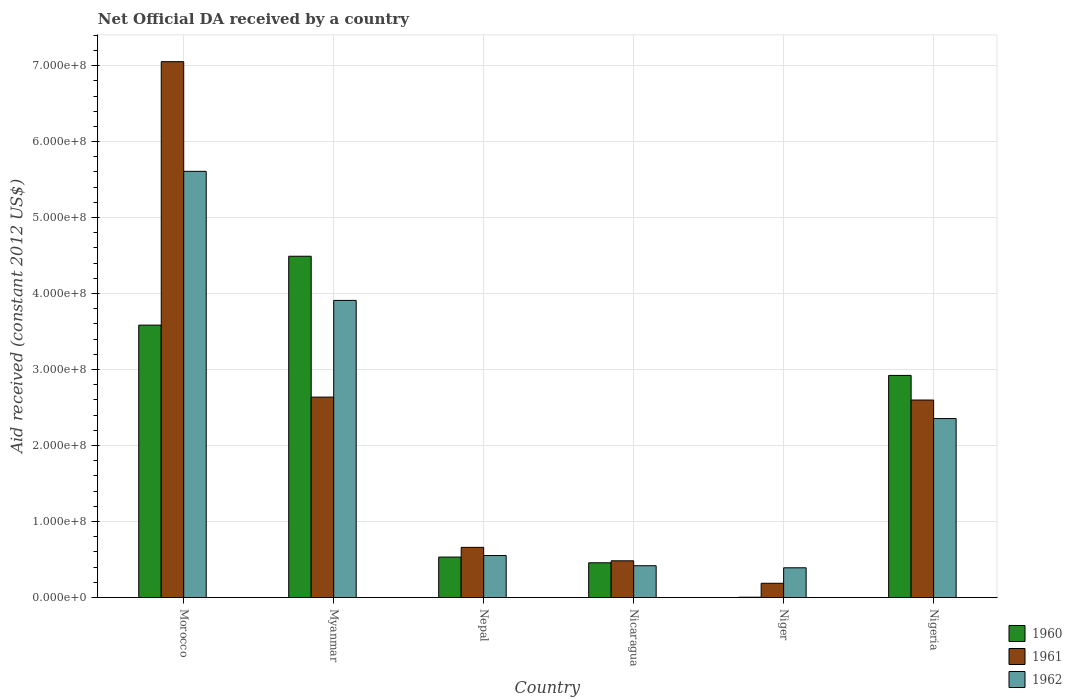How many groups of bars are there?
Offer a terse response. 6. Are the number of bars on each tick of the X-axis equal?
Make the answer very short. Yes. How many bars are there on the 2nd tick from the left?
Make the answer very short. 3. What is the label of the 2nd group of bars from the left?
Your answer should be very brief. Myanmar. What is the net official development assistance aid received in 1961 in Nigeria?
Your response must be concise. 2.60e+08. Across all countries, what is the maximum net official development assistance aid received in 1960?
Provide a short and direct response. 4.49e+08. Across all countries, what is the minimum net official development assistance aid received in 1961?
Your answer should be very brief. 1.88e+07. In which country was the net official development assistance aid received in 1960 maximum?
Your answer should be very brief. Myanmar. In which country was the net official development assistance aid received in 1962 minimum?
Your answer should be compact. Niger. What is the total net official development assistance aid received in 1961 in the graph?
Your answer should be very brief. 1.36e+09. What is the difference between the net official development assistance aid received in 1961 in Morocco and that in Myanmar?
Provide a short and direct response. 4.41e+08. What is the difference between the net official development assistance aid received in 1962 in Niger and the net official development assistance aid received in 1960 in Morocco?
Give a very brief answer. -3.19e+08. What is the average net official development assistance aid received in 1961 per country?
Provide a short and direct response. 2.27e+08. What is the difference between the net official development assistance aid received of/in 1961 and net official development assistance aid received of/in 1960 in Niger?
Provide a succinct answer. 1.84e+07. What is the ratio of the net official development assistance aid received in 1961 in Nicaragua to that in Niger?
Your response must be concise. 2.58. Is the net official development assistance aid received in 1961 in Morocco less than that in Nigeria?
Offer a very short reply. No. What is the difference between the highest and the second highest net official development assistance aid received in 1962?
Offer a terse response. 3.25e+08. What is the difference between the highest and the lowest net official development assistance aid received in 1960?
Offer a terse response. 4.49e+08. In how many countries, is the net official development assistance aid received in 1962 greater than the average net official development assistance aid received in 1962 taken over all countries?
Provide a succinct answer. 3. What does the 3rd bar from the left in Nicaragua represents?
Offer a terse response. 1962. What does the 2nd bar from the right in Nepal represents?
Offer a very short reply. 1961. Is it the case that in every country, the sum of the net official development assistance aid received in 1961 and net official development assistance aid received in 1962 is greater than the net official development assistance aid received in 1960?
Offer a very short reply. Yes. How many bars are there?
Provide a short and direct response. 18. How many countries are there in the graph?
Provide a short and direct response. 6. Does the graph contain grids?
Provide a succinct answer. Yes. Where does the legend appear in the graph?
Offer a terse response. Bottom right. What is the title of the graph?
Offer a terse response. Net Official DA received by a country. Does "1974" appear as one of the legend labels in the graph?
Your answer should be very brief. No. What is the label or title of the Y-axis?
Make the answer very short. Aid received (constant 2012 US$). What is the Aid received (constant 2012 US$) of 1960 in Morocco?
Give a very brief answer. 3.58e+08. What is the Aid received (constant 2012 US$) in 1961 in Morocco?
Your response must be concise. 7.05e+08. What is the Aid received (constant 2012 US$) in 1962 in Morocco?
Offer a terse response. 5.61e+08. What is the Aid received (constant 2012 US$) of 1960 in Myanmar?
Provide a short and direct response. 4.49e+08. What is the Aid received (constant 2012 US$) in 1961 in Myanmar?
Provide a succinct answer. 2.64e+08. What is the Aid received (constant 2012 US$) of 1962 in Myanmar?
Give a very brief answer. 3.91e+08. What is the Aid received (constant 2012 US$) in 1960 in Nepal?
Offer a terse response. 5.32e+07. What is the Aid received (constant 2012 US$) in 1961 in Nepal?
Give a very brief answer. 6.60e+07. What is the Aid received (constant 2012 US$) in 1962 in Nepal?
Provide a succinct answer. 5.53e+07. What is the Aid received (constant 2012 US$) of 1960 in Nicaragua?
Provide a short and direct response. 4.57e+07. What is the Aid received (constant 2012 US$) in 1961 in Nicaragua?
Provide a succinct answer. 4.83e+07. What is the Aid received (constant 2012 US$) of 1962 in Nicaragua?
Make the answer very short. 4.18e+07. What is the Aid received (constant 2012 US$) of 1961 in Niger?
Your answer should be compact. 1.88e+07. What is the Aid received (constant 2012 US$) of 1962 in Niger?
Your answer should be compact. 3.91e+07. What is the Aid received (constant 2012 US$) of 1960 in Nigeria?
Your response must be concise. 2.92e+08. What is the Aid received (constant 2012 US$) of 1961 in Nigeria?
Keep it short and to the point. 2.60e+08. What is the Aid received (constant 2012 US$) in 1962 in Nigeria?
Your answer should be compact. 2.36e+08. Across all countries, what is the maximum Aid received (constant 2012 US$) in 1960?
Provide a succinct answer. 4.49e+08. Across all countries, what is the maximum Aid received (constant 2012 US$) in 1961?
Offer a terse response. 7.05e+08. Across all countries, what is the maximum Aid received (constant 2012 US$) in 1962?
Make the answer very short. 5.61e+08. Across all countries, what is the minimum Aid received (constant 2012 US$) of 1960?
Offer a terse response. 4.10e+05. Across all countries, what is the minimum Aid received (constant 2012 US$) of 1961?
Make the answer very short. 1.88e+07. Across all countries, what is the minimum Aid received (constant 2012 US$) in 1962?
Provide a succinct answer. 3.91e+07. What is the total Aid received (constant 2012 US$) of 1960 in the graph?
Ensure brevity in your answer.  1.20e+09. What is the total Aid received (constant 2012 US$) of 1961 in the graph?
Offer a very short reply. 1.36e+09. What is the total Aid received (constant 2012 US$) of 1962 in the graph?
Offer a very short reply. 1.32e+09. What is the difference between the Aid received (constant 2012 US$) of 1960 in Morocco and that in Myanmar?
Your answer should be compact. -9.06e+07. What is the difference between the Aid received (constant 2012 US$) of 1961 in Morocco and that in Myanmar?
Ensure brevity in your answer.  4.41e+08. What is the difference between the Aid received (constant 2012 US$) of 1962 in Morocco and that in Myanmar?
Ensure brevity in your answer.  1.70e+08. What is the difference between the Aid received (constant 2012 US$) in 1960 in Morocco and that in Nepal?
Ensure brevity in your answer.  3.05e+08. What is the difference between the Aid received (constant 2012 US$) of 1961 in Morocco and that in Nepal?
Provide a short and direct response. 6.39e+08. What is the difference between the Aid received (constant 2012 US$) of 1962 in Morocco and that in Nepal?
Ensure brevity in your answer.  5.06e+08. What is the difference between the Aid received (constant 2012 US$) of 1960 in Morocco and that in Nicaragua?
Your answer should be compact. 3.13e+08. What is the difference between the Aid received (constant 2012 US$) in 1961 in Morocco and that in Nicaragua?
Your response must be concise. 6.57e+08. What is the difference between the Aid received (constant 2012 US$) of 1962 in Morocco and that in Nicaragua?
Provide a succinct answer. 5.19e+08. What is the difference between the Aid received (constant 2012 US$) of 1960 in Morocco and that in Niger?
Give a very brief answer. 3.58e+08. What is the difference between the Aid received (constant 2012 US$) in 1961 in Morocco and that in Niger?
Make the answer very short. 6.86e+08. What is the difference between the Aid received (constant 2012 US$) in 1962 in Morocco and that in Niger?
Ensure brevity in your answer.  5.22e+08. What is the difference between the Aid received (constant 2012 US$) of 1960 in Morocco and that in Nigeria?
Offer a very short reply. 6.62e+07. What is the difference between the Aid received (constant 2012 US$) of 1961 in Morocco and that in Nigeria?
Your answer should be very brief. 4.45e+08. What is the difference between the Aid received (constant 2012 US$) of 1962 in Morocco and that in Nigeria?
Ensure brevity in your answer.  3.25e+08. What is the difference between the Aid received (constant 2012 US$) of 1960 in Myanmar and that in Nepal?
Provide a short and direct response. 3.96e+08. What is the difference between the Aid received (constant 2012 US$) of 1961 in Myanmar and that in Nepal?
Make the answer very short. 1.98e+08. What is the difference between the Aid received (constant 2012 US$) in 1962 in Myanmar and that in Nepal?
Your answer should be very brief. 3.36e+08. What is the difference between the Aid received (constant 2012 US$) in 1960 in Myanmar and that in Nicaragua?
Offer a terse response. 4.03e+08. What is the difference between the Aid received (constant 2012 US$) of 1961 in Myanmar and that in Nicaragua?
Give a very brief answer. 2.15e+08. What is the difference between the Aid received (constant 2012 US$) of 1962 in Myanmar and that in Nicaragua?
Give a very brief answer. 3.49e+08. What is the difference between the Aid received (constant 2012 US$) of 1960 in Myanmar and that in Niger?
Your answer should be very brief. 4.49e+08. What is the difference between the Aid received (constant 2012 US$) in 1961 in Myanmar and that in Niger?
Provide a succinct answer. 2.45e+08. What is the difference between the Aid received (constant 2012 US$) in 1962 in Myanmar and that in Niger?
Ensure brevity in your answer.  3.52e+08. What is the difference between the Aid received (constant 2012 US$) of 1960 in Myanmar and that in Nigeria?
Your answer should be compact. 1.57e+08. What is the difference between the Aid received (constant 2012 US$) in 1961 in Myanmar and that in Nigeria?
Make the answer very short. 3.86e+06. What is the difference between the Aid received (constant 2012 US$) of 1962 in Myanmar and that in Nigeria?
Offer a terse response. 1.56e+08. What is the difference between the Aid received (constant 2012 US$) in 1960 in Nepal and that in Nicaragua?
Offer a very short reply. 7.52e+06. What is the difference between the Aid received (constant 2012 US$) in 1961 in Nepal and that in Nicaragua?
Offer a very short reply. 1.77e+07. What is the difference between the Aid received (constant 2012 US$) in 1962 in Nepal and that in Nicaragua?
Provide a succinct answer. 1.34e+07. What is the difference between the Aid received (constant 2012 US$) of 1960 in Nepal and that in Niger?
Give a very brief answer. 5.28e+07. What is the difference between the Aid received (constant 2012 US$) in 1961 in Nepal and that in Niger?
Ensure brevity in your answer.  4.72e+07. What is the difference between the Aid received (constant 2012 US$) in 1962 in Nepal and that in Niger?
Keep it short and to the point. 1.62e+07. What is the difference between the Aid received (constant 2012 US$) of 1960 in Nepal and that in Nigeria?
Your response must be concise. -2.39e+08. What is the difference between the Aid received (constant 2012 US$) in 1961 in Nepal and that in Nigeria?
Keep it short and to the point. -1.94e+08. What is the difference between the Aid received (constant 2012 US$) of 1962 in Nepal and that in Nigeria?
Offer a terse response. -1.80e+08. What is the difference between the Aid received (constant 2012 US$) in 1960 in Nicaragua and that in Niger?
Give a very brief answer. 4.53e+07. What is the difference between the Aid received (constant 2012 US$) of 1961 in Nicaragua and that in Niger?
Your answer should be compact. 2.96e+07. What is the difference between the Aid received (constant 2012 US$) in 1962 in Nicaragua and that in Niger?
Your answer should be compact. 2.72e+06. What is the difference between the Aid received (constant 2012 US$) in 1960 in Nicaragua and that in Nigeria?
Give a very brief answer. -2.47e+08. What is the difference between the Aid received (constant 2012 US$) of 1961 in Nicaragua and that in Nigeria?
Make the answer very short. -2.12e+08. What is the difference between the Aid received (constant 2012 US$) of 1962 in Nicaragua and that in Nigeria?
Offer a terse response. -1.94e+08. What is the difference between the Aid received (constant 2012 US$) in 1960 in Niger and that in Nigeria?
Make the answer very short. -2.92e+08. What is the difference between the Aid received (constant 2012 US$) in 1961 in Niger and that in Nigeria?
Provide a short and direct response. -2.41e+08. What is the difference between the Aid received (constant 2012 US$) in 1962 in Niger and that in Nigeria?
Keep it short and to the point. -1.96e+08. What is the difference between the Aid received (constant 2012 US$) in 1960 in Morocco and the Aid received (constant 2012 US$) in 1961 in Myanmar?
Your answer should be very brief. 9.47e+07. What is the difference between the Aid received (constant 2012 US$) of 1960 in Morocco and the Aid received (constant 2012 US$) of 1962 in Myanmar?
Offer a terse response. -3.25e+07. What is the difference between the Aid received (constant 2012 US$) of 1961 in Morocco and the Aid received (constant 2012 US$) of 1962 in Myanmar?
Offer a very short reply. 3.14e+08. What is the difference between the Aid received (constant 2012 US$) of 1960 in Morocco and the Aid received (constant 2012 US$) of 1961 in Nepal?
Make the answer very short. 2.92e+08. What is the difference between the Aid received (constant 2012 US$) in 1960 in Morocco and the Aid received (constant 2012 US$) in 1962 in Nepal?
Your response must be concise. 3.03e+08. What is the difference between the Aid received (constant 2012 US$) of 1961 in Morocco and the Aid received (constant 2012 US$) of 1962 in Nepal?
Give a very brief answer. 6.50e+08. What is the difference between the Aid received (constant 2012 US$) of 1960 in Morocco and the Aid received (constant 2012 US$) of 1961 in Nicaragua?
Provide a succinct answer. 3.10e+08. What is the difference between the Aid received (constant 2012 US$) in 1960 in Morocco and the Aid received (constant 2012 US$) in 1962 in Nicaragua?
Make the answer very short. 3.17e+08. What is the difference between the Aid received (constant 2012 US$) of 1961 in Morocco and the Aid received (constant 2012 US$) of 1962 in Nicaragua?
Give a very brief answer. 6.63e+08. What is the difference between the Aid received (constant 2012 US$) of 1960 in Morocco and the Aid received (constant 2012 US$) of 1961 in Niger?
Offer a very short reply. 3.40e+08. What is the difference between the Aid received (constant 2012 US$) of 1960 in Morocco and the Aid received (constant 2012 US$) of 1962 in Niger?
Provide a short and direct response. 3.19e+08. What is the difference between the Aid received (constant 2012 US$) of 1961 in Morocco and the Aid received (constant 2012 US$) of 1962 in Niger?
Your answer should be compact. 6.66e+08. What is the difference between the Aid received (constant 2012 US$) in 1960 in Morocco and the Aid received (constant 2012 US$) in 1961 in Nigeria?
Offer a terse response. 9.86e+07. What is the difference between the Aid received (constant 2012 US$) of 1960 in Morocco and the Aid received (constant 2012 US$) of 1962 in Nigeria?
Your response must be concise. 1.23e+08. What is the difference between the Aid received (constant 2012 US$) of 1961 in Morocco and the Aid received (constant 2012 US$) of 1962 in Nigeria?
Keep it short and to the point. 4.70e+08. What is the difference between the Aid received (constant 2012 US$) in 1960 in Myanmar and the Aid received (constant 2012 US$) in 1961 in Nepal?
Your answer should be compact. 3.83e+08. What is the difference between the Aid received (constant 2012 US$) of 1960 in Myanmar and the Aid received (constant 2012 US$) of 1962 in Nepal?
Provide a short and direct response. 3.94e+08. What is the difference between the Aid received (constant 2012 US$) of 1961 in Myanmar and the Aid received (constant 2012 US$) of 1962 in Nepal?
Provide a succinct answer. 2.08e+08. What is the difference between the Aid received (constant 2012 US$) in 1960 in Myanmar and the Aid received (constant 2012 US$) in 1961 in Nicaragua?
Provide a short and direct response. 4.01e+08. What is the difference between the Aid received (constant 2012 US$) of 1960 in Myanmar and the Aid received (constant 2012 US$) of 1962 in Nicaragua?
Your answer should be compact. 4.07e+08. What is the difference between the Aid received (constant 2012 US$) in 1961 in Myanmar and the Aid received (constant 2012 US$) in 1962 in Nicaragua?
Ensure brevity in your answer.  2.22e+08. What is the difference between the Aid received (constant 2012 US$) of 1960 in Myanmar and the Aid received (constant 2012 US$) of 1961 in Niger?
Provide a short and direct response. 4.30e+08. What is the difference between the Aid received (constant 2012 US$) of 1960 in Myanmar and the Aid received (constant 2012 US$) of 1962 in Niger?
Your response must be concise. 4.10e+08. What is the difference between the Aid received (constant 2012 US$) in 1961 in Myanmar and the Aid received (constant 2012 US$) in 1962 in Niger?
Make the answer very short. 2.25e+08. What is the difference between the Aid received (constant 2012 US$) of 1960 in Myanmar and the Aid received (constant 2012 US$) of 1961 in Nigeria?
Your answer should be very brief. 1.89e+08. What is the difference between the Aid received (constant 2012 US$) of 1960 in Myanmar and the Aid received (constant 2012 US$) of 1962 in Nigeria?
Your answer should be compact. 2.14e+08. What is the difference between the Aid received (constant 2012 US$) of 1961 in Myanmar and the Aid received (constant 2012 US$) of 1962 in Nigeria?
Ensure brevity in your answer.  2.82e+07. What is the difference between the Aid received (constant 2012 US$) in 1960 in Nepal and the Aid received (constant 2012 US$) in 1961 in Nicaragua?
Provide a succinct answer. 4.90e+06. What is the difference between the Aid received (constant 2012 US$) of 1960 in Nepal and the Aid received (constant 2012 US$) of 1962 in Nicaragua?
Your answer should be very brief. 1.14e+07. What is the difference between the Aid received (constant 2012 US$) in 1961 in Nepal and the Aid received (constant 2012 US$) in 1962 in Nicaragua?
Offer a very short reply. 2.42e+07. What is the difference between the Aid received (constant 2012 US$) of 1960 in Nepal and the Aid received (constant 2012 US$) of 1961 in Niger?
Provide a succinct answer. 3.45e+07. What is the difference between the Aid received (constant 2012 US$) in 1960 in Nepal and the Aid received (constant 2012 US$) in 1962 in Niger?
Make the answer very short. 1.41e+07. What is the difference between the Aid received (constant 2012 US$) in 1961 in Nepal and the Aid received (constant 2012 US$) in 1962 in Niger?
Offer a terse response. 2.69e+07. What is the difference between the Aid received (constant 2012 US$) of 1960 in Nepal and the Aid received (constant 2012 US$) of 1961 in Nigeria?
Provide a short and direct response. -2.07e+08. What is the difference between the Aid received (constant 2012 US$) of 1960 in Nepal and the Aid received (constant 2012 US$) of 1962 in Nigeria?
Offer a terse response. -1.82e+08. What is the difference between the Aid received (constant 2012 US$) of 1961 in Nepal and the Aid received (constant 2012 US$) of 1962 in Nigeria?
Your answer should be compact. -1.70e+08. What is the difference between the Aid received (constant 2012 US$) of 1960 in Nicaragua and the Aid received (constant 2012 US$) of 1961 in Niger?
Keep it short and to the point. 2.70e+07. What is the difference between the Aid received (constant 2012 US$) of 1960 in Nicaragua and the Aid received (constant 2012 US$) of 1962 in Niger?
Provide a short and direct response. 6.58e+06. What is the difference between the Aid received (constant 2012 US$) of 1961 in Nicaragua and the Aid received (constant 2012 US$) of 1962 in Niger?
Make the answer very short. 9.20e+06. What is the difference between the Aid received (constant 2012 US$) in 1960 in Nicaragua and the Aid received (constant 2012 US$) in 1961 in Nigeria?
Your answer should be compact. -2.14e+08. What is the difference between the Aid received (constant 2012 US$) of 1960 in Nicaragua and the Aid received (constant 2012 US$) of 1962 in Nigeria?
Offer a very short reply. -1.90e+08. What is the difference between the Aid received (constant 2012 US$) in 1961 in Nicaragua and the Aid received (constant 2012 US$) in 1962 in Nigeria?
Give a very brief answer. -1.87e+08. What is the difference between the Aid received (constant 2012 US$) of 1960 in Niger and the Aid received (constant 2012 US$) of 1961 in Nigeria?
Offer a terse response. -2.59e+08. What is the difference between the Aid received (constant 2012 US$) in 1960 in Niger and the Aid received (constant 2012 US$) in 1962 in Nigeria?
Provide a succinct answer. -2.35e+08. What is the difference between the Aid received (constant 2012 US$) of 1961 in Niger and the Aid received (constant 2012 US$) of 1962 in Nigeria?
Offer a terse response. -2.17e+08. What is the average Aid received (constant 2012 US$) of 1960 per country?
Provide a succinct answer. 2.00e+08. What is the average Aid received (constant 2012 US$) in 1961 per country?
Keep it short and to the point. 2.27e+08. What is the average Aid received (constant 2012 US$) of 1962 per country?
Provide a succinct answer. 2.21e+08. What is the difference between the Aid received (constant 2012 US$) of 1960 and Aid received (constant 2012 US$) of 1961 in Morocco?
Make the answer very short. -3.47e+08. What is the difference between the Aid received (constant 2012 US$) of 1960 and Aid received (constant 2012 US$) of 1962 in Morocco?
Provide a succinct answer. -2.02e+08. What is the difference between the Aid received (constant 2012 US$) in 1961 and Aid received (constant 2012 US$) in 1962 in Morocco?
Ensure brevity in your answer.  1.44e+08. What is the difference between the Aid received (constant 2012 US$) of 1960 and Aid received (constant 2012 US$) of 1961 in Myanmar?
Give a very brief answer. 1.85e+08. What is the difference between the Aid received (constant 2012 US$) of 1960 and Aid received (constant 2012 US$) of 1962 in Myanmar?
Your response must be concise. 5.81e+07. What is the difference between the Aid received (constant 2012 US$) in 1961 and Aid received (constant 2012 US$) in 1962 in Myanmar?
Offer a very short reply. -1.27e+08. What is the difference between the Aid received (constant 2012 US$) of 1960 and Aid received (constant 2012 US$) of 1961 in Nepal?
Offer a terse response. -1.28e+07. What is the difference between the Aid received (constant 2012 US$) in 1960 and Aid received (constant 2012 US$) in 1962 in Nepal?
Your answer should be very brief. -2.05e+06. What is the difference between the Aid received (constant 2012 US$) in 1961 and Aid received (constant 2012 US$) in 1962 in Nepal?
Your response must be concise. 1.07e+07. What is the difference between the Aid received (constant 2012 US$) of 1960 and Aid received (constant 2012 US$) of 1961 in Nicaragua?
Your response must be concise. -2.62e+06. What is the difference between the Aid received (constant 2012 US$) of 1960 and Aid received (constant 2012 US$) of 1962 in Nicaragua?
Your answer should be compact. 3.86e+06. What is the difference between the Aid received (constant 2012 US$) of 1961 and Aid received (constant 2012 US$) of 1962 in Nicaragua?
Provide a succinct answer. 6.48e+06. What is the difference between the Aid received (constant 2012 US$) in 1960 and Aid received (constant 2012 US$) in 1961 in Niger?
Ensure brevity in your answer.  -1.84e+07. What is the difference between the Aid received (constant 2012 US$) in 1960 and Aid received (constant 2012 US$) in 1962 in Niger?
Provide a short and direct response. -3.87e+07. What is the difference between the Aid received (constant 2012 US$) in 1961 and Aid received (constant 2012 US$) in 1962 in Niger?
Make the answer very short. -2.04e+07. What is the difference between the Aid received (constant 2012 US$) in 1960 and Aid received (constant 2012 US$) in 1961 in Nigeria?
Provide a succinct answer. 3.24e+07. What is the difference between the Aid received (constant 2012 US$) in 1960 and Aid received (constant 2012 US$) in 1962 in Nigeria?
Your answer should be compact. 5.68e+07. What is the difference between the Aid received (constant 2012 US$) of 1961 and Aid received (constant 2012 US$) of 1962 in Nigeria?
Ensure brevity in your answer.  2.44e+07. What is the ratio of the Aid received (constant 2012 US$) in 1960 in Morocco to that in Myanmar?
Your response must be concise. 0.8. What is the ratio of the Aid received (constant 2012 US$) of 1961 in Morocco to that in Myanmar?
Offer a very short reply. 2.67. What is the ratio of the Aid received (constant 2012 US$) of 1962 in Morocco to that in Myanmar?
Provide a succinct answer. 1.43. What is the ratio of the Aid received (constant 2012 US$) in 1960 in Morocco to that in Nepal?
Keep it short and to the point. 6.73. What is the ratio of the Aid received (constant 2012 US$) of 1961 in Morocco to that in Nepal?
Make the answer very short. 10.68. What is the ratio of the Aid received (constant 2012 US$) of 1962 in Morocco to that in Nepal?
Offer a terse response. 10.15. What is the ratio of the Aid received (constant 2012 US$) of 1960 in Morocco to that in Nicaragua?
Your answer should be compact. 7.84. What is the ratio of the Aid received (constant 2012 US$) of 1961 in Morocco to that in Nicaragua?
Give a very brief answer. 14.59. What is the ratio of the Aid received (constant 2012 US$) in 1962 in Morocco to that in Nicaragua?
Offer a very short reply. 13.4. What is the ratio of the Aid received (constant 2012 US$) of 1960 in Morocco to that in Niger?
Make the answer very short. 874.39. What is the ratio of the Aid received (constant 2012 US$) in 1961 in Morocco to that in Niger?
Your response must be concise. 37.59. What is the ratio of the Aid received (constant 2012 US$) in 1962 in Morocco to that in Niger?
Make the answer very short. 14.33. What is the ratio of the Aid received (constant 2012 US$) of 1960 in Morocco to that in Nigeria?
Keep it short and to the point. 1.23. What is the ratio of the Aid received (constant 2012 US$) in 1961 in Morocco to that in Nigeria?
Your answer should be very brief. 2.71. What is the ratio of the Aid received (constant 2012 US$) in 1962 in Morocco to that in Nigeria?
Give a very brief answer. 2.38. What is the ratio of the Aid received (constant 2012 US$) in 1960 in Myanmar to that in Nepal?
Your answer should be very brief. 8.44. What is the ratio of the Aid received (constant 2012 US$) in 1961 in Myanmar to that in Nepal?
Provide a succinct answer. 4. What is the ratio of the Aid received (constant 2012 US$) in 1962 in Myanmar to that in Nepal?
Offer a very short reply. 7.07. What is the ratio of the Aid received (constant 2012 US$) of 1960 in Myanmar to that in Nicaragua?
Ensure brevity in your answer.  9.83. What is the ratio of the Aid received (constant 2012 US$) of 1961 in Myanmar to that in Nicaragua?
Provide a succinct answer. 5.46. What is the ratio of the Aid received (constant 2012 US$) of 1962 in Myanmar to that in Nicaragua?
Ensure brevity in your answer.  9.34. What is the ratio of the Aid received (constant 2012 US$) in 1960 in Myanmar to that in Niger?
Make the answer very short. 1095.46. What is the ratio of the Aid received (constant 2012 US$) in 1961 in Myanmar to that in Niger?
Provide a succinct answer. 14.06. What is the ratio of the Aid received (constant 2012 US$) of 1962 in Myanmar to that in Niger?
Your answer should be very brief. 9.99. What is the ratio of the Aid received (constant 2012 US$) in 1960 in Myanmar to that in Nigeria?
Your response must be concise. 1.54. What is the ratio of the Aid received (constant 2012 US$) of 1961 in Myanmar to that in Nigeria?
Give a very brief answer. 1.01. What is the ratio of the Aid received (constant 2012 US$) of 1962 in Myanmar to that in Nigeria?
Make the answer very short. 1.66. What is the ratio of the Aid received (constant 2012 US$) in 1960 in Nepal to that in Nicaragua?
Provide a short and direct response. 1.16. What is the ratio of the Aid received (constant 2012 US$) in 1961 in Nepal to that in Nicaragua?
Your response must be concise. 1.37. What is the ratio of the Aid received (constant 2012 US$) of 1962 in Nepal to that in Nicaragua?
Make the answer very short. 1.32. What is the ratio of the Aid received (constant 2012 US$) in 1960 in Nepal to that in Niger?
Keep it short and to the point. 129.83. What is the ratio of the Aid received (constant 2012 US$) in 1961 in Nepal to that in Niger?
Your response must be concise. 3.52. What is the ratio of the Aid received (constant 2012 US$) of 1962 in Nepal to that in Niger?
Offer a terse response. 1.41. What is the ratio of the Aid received (constant 2012 US$) of 1960 in Nepal to that in Nigeria?
Offer a very short reply. 0.18. What is the ratio of the Aid received (constant 2012 US$) of 1961 in Nepal to that in Nigeria?
Your answer should be very brief. 0.25. What is the ratio of the Aid received (constant 2012 US$) of 1962 in Nepal to that in Nigeria?
Your answer should be compact. 0.23. What is the ratio of the Aid received (constant 2012 US$) of 1960 in Nicaragua to that in Niger?
Offer a very short reply. 111.49. What is the ratio of the Aid received (constant 2012 US$) in 1961 in Nicaragua to that in Niger?
Make the answer very short. 2.58. What is the ratio of the Aid received (constant 2012 US$) of 1962 in Nicaragua to that in Niger?
Provide a short and direct response. 1.07. What is the ratio of the Aid received (constant 2012 US$) of 1960 in Nicaragua to that in Nigeria?
Your answer should be very brief. 0.16. What is the ratio of the Aid received (constant 2012 US$) of 1961 in Nicaragua to that in Nigeria?
Your answer should be compact. 0.19. What is the ratio of the Aid received (constant 2012 US$) of 1962 in Nicaragua to that in Nigeria?
Your response must be concise. 0.18. What is the ratio of the Aid received (constant 2012 US$) in 1960 in Niger to that in Nigeria?
Offer a very short reply. 0. What is the ratio of the Aid received (constant 2012 US$) in 1961 in Niger to that in Nigeria?
Your response must be concise. 0.07. What is the ratio of the Aid received (constant 2012 US$) in 1962 in Niger to that in Nigeria?
Keep it short and to the point. 0.17. What is the difference between the highest and the second highest Aid received (constant 2012 US$) in 1960?
Keep it short and to the point. 9.06e+07. What is the difference between the highest and the second highest Aid received (constant 2012 US$) in 1961?
Provide a succinct answer. 4.41e+08. What is the difference between the highest and the second highest Aid received (constant 2012 US$) in 1962?
Your response must be concise. 1.70e+08. What is the difference between the highest and the lowest Aid received (constant 2012 US$) of 1960?
Provide a succinct answer. 4.49e+08. What is the difference between the highest and the lowest Aid received (constant 2012 US$) in 1961?
Make the answer very short. 6.86e+08. What is the difference between the highest and the lowest Aid received (constant 2012 US$) in 1962?
Ensure brevity in your answer.  5.22e+08. 